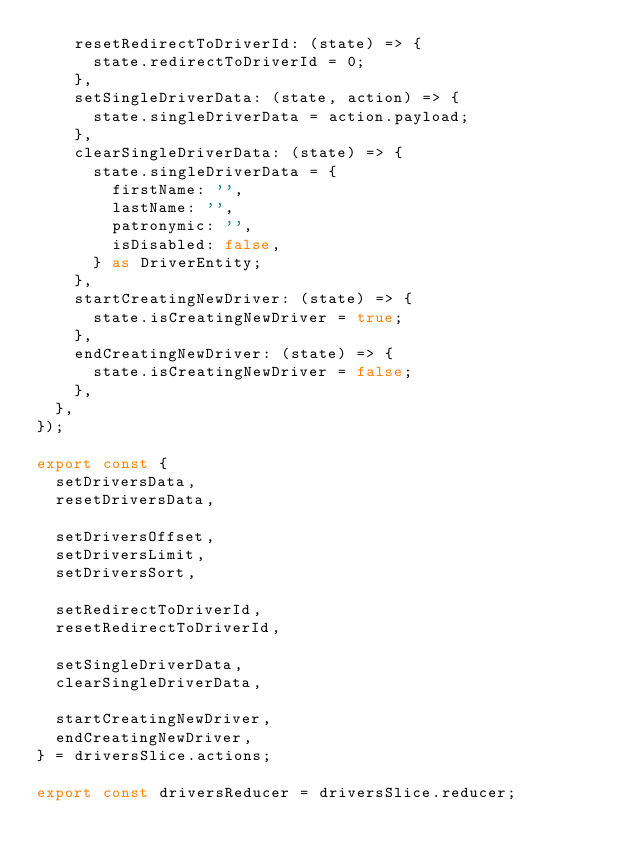Convert code to text. <code><loc_0><loc_0><loc_500><loc_500><_TypeScript_>    resetRedirectToDriverId: (state) => {
      state.redirectToDriverId = 0;
    },
    setSingleDriverData: (state, action) => {
      state.singleDriverData = action.payload;
    },
    clearSingleDriverData: (state) => {
      state.singleDriverData = {
        firstName: '',
        lastName: '',
        patronymic: '',
        isDisabled: false,
      } as DriverEntity;
    },
    startCreatingNewDriver: (state) => {
      state.isCreatingNewDriver = true;
    },
    endCreatingNewDriver: (state) => {
      state.isCreatingNewDriver = false;
    },
  },
});

export const {
  setDriversData,
  resetDriversData,

  setDriversOffset,
  setDriversLimit,
  setDriversSort,

  setRedirectToDriverId,
  resetRedirectToDriverId,

  setSingleDriverData,
  clearSingleDriverData,

  startCreatingNewDriver,
  endCreatingNewDriver,
} = driversSlice.actions;

export const driversReducer = driversSlice.reducer;
</code> 